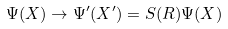<formula> <loc_0><loc_0><loc_500><loc_500>\Psi ( X ) \rightarrow \Psi ^ { \prime } ( X ^ { \prime } ) = S ( R ) \Psi ( X )</formula> 